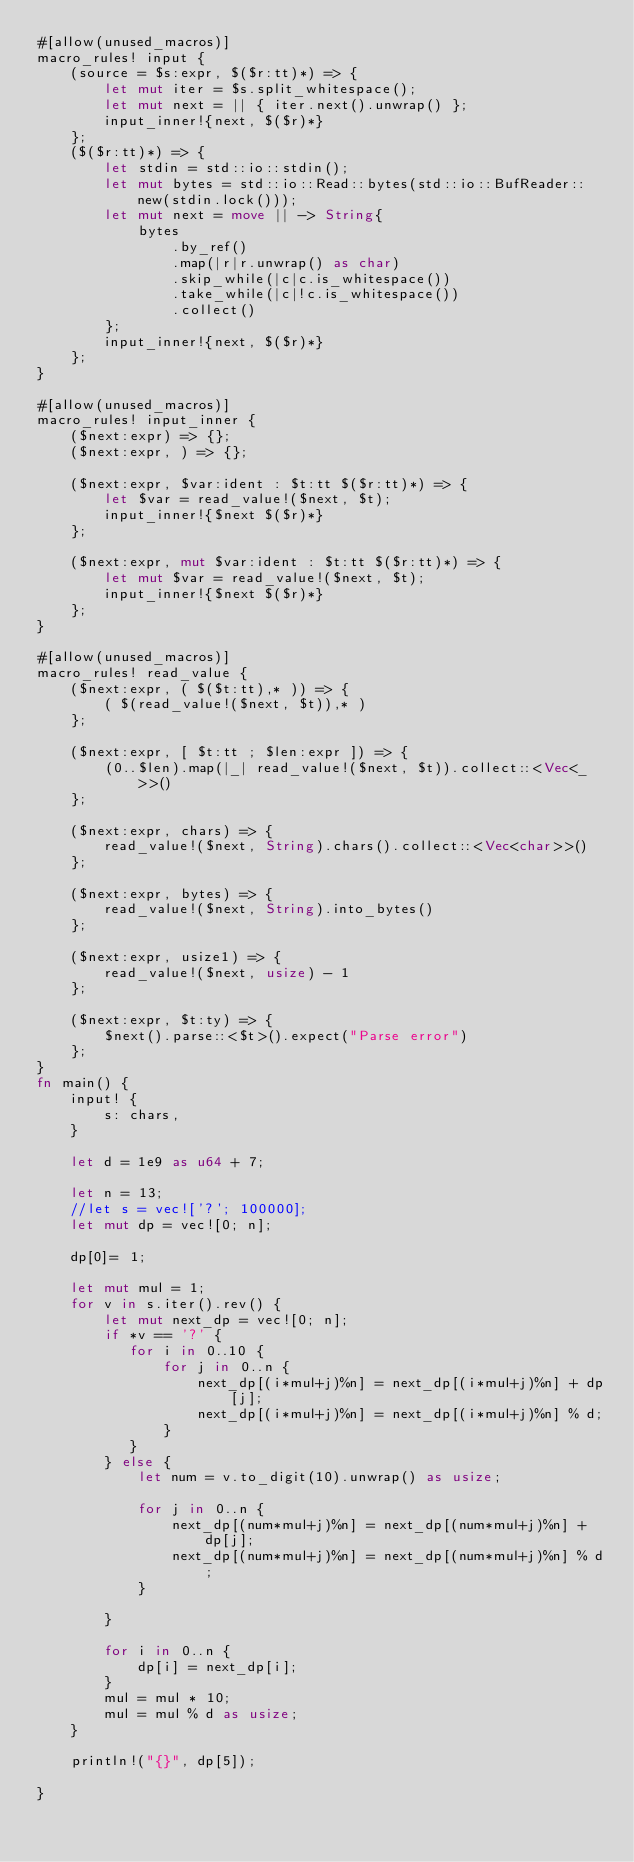Convert code to text. <code><loc_0><loc_0><loc_500><loc_500><_Rust_>#[allow(unused_macros)]
macro_rules! input {
    (source = $s:expr, $($r:tt)*) => {
        let mut iter = $s.split_whitespace();
        let mut next = || { iter.next().unwrap() };
        input_inner!{next, $($r)*}
    };
    ($($r:tt)*) => {
        let stdin = std::io::stdin();
        let mut bytes = std::io::Read::bytes(std::io::BufReader::new(stdin.lock()));
        let mut next = move || -> String{
            bytes
                .by_ref()
                .map(|r|r.unwrap() as char)
                .skip_while(|c|c.is_whitespace())
                .take_while(|c|!c.is_whitespace())
                .collect()
        };
        input_inner!{next, $($r)*}
    };
}
 
#[allow(unused_macros)]
macro_rules! input_inner {
    ($next:expr) => {};
    ($next:expr, ) => {};
 
    ($next:expr, $var:ident : $t:tt $($r:tt)*) => {
        let $var = read_value!($next, $t);
        input_inner!{$next $($r)*}
    };
 
    ($next:expr, mut $var:ident : $t:tt $($r:tt)*) => {
        let mut $var = read_value!($next, $t);
        input_inner!{$next $($r)*}
    };
}
 
#[allow(unused_macros)]
macro_rules! read_value {
    ($next:expr, ( $($t:tt),* )) => {
        ( $(read_value!($next, $t)),* )
    };
 
    ($next:expr, [ $t:tt ; $len:expr ]) => {
        (0..$len).map(|_| read_value!($next, $t)).collect::<Vec<_>>()
    };
 
    ($next:expr, chars) => {
        read_value!($next, String).chars().collect::<Vec<char>>()
    };
 
    ($next:expr, bytes) => {
        read_value!($next, String).into_bytes()
    };
 
    ($next:expr, usize1) => {
        read_value!($next, usize) - 1
    };
 
    ($next:expr, $t:ty) => {
        $next().parse::<$t>().expect("Parse error")
    };
}
fn main() {
    input! {
        s: chars,
    }

    let d = 1e9 as u64 + 7;

    let n = 13;
    //let s = vec!['?'; 100000];
    let mut dp = vec![0; n];

    dp[0]= 1;

    let mut mul = 1;
    for v in s.iter().rev() {
        let mut next_dp = vec![0; n];
        if *v == '?' {
           for i in 0..10 {
               for j in 0..n {
                   next_dp[(i*mul+j)%n] = next_dp[(i*mul+j)%n] + dp[j];
                   next_dp[(i*mul+j)%n] = next_dp[(i*mul+j)%n] % d;
               }
           } 
        } else {
            let num = v.to_digit(10).unwrap() as usize;

            for j in 0..n {
                next_dp[(num*mul+j)%n] = next_dp[(num*mul+j)%n] + dp[j];
                next_dp[(num*mul+j)%n] = next_dp[(num*mul+j)%n] % d;
            }

        }

        for i in 0..n {
            dp[i] = next_dp[i];
        }
        mul = mul * 10;
        mul = mul % d as usize;
    }

    println!("{}", dp[5]);  

}
</code> 